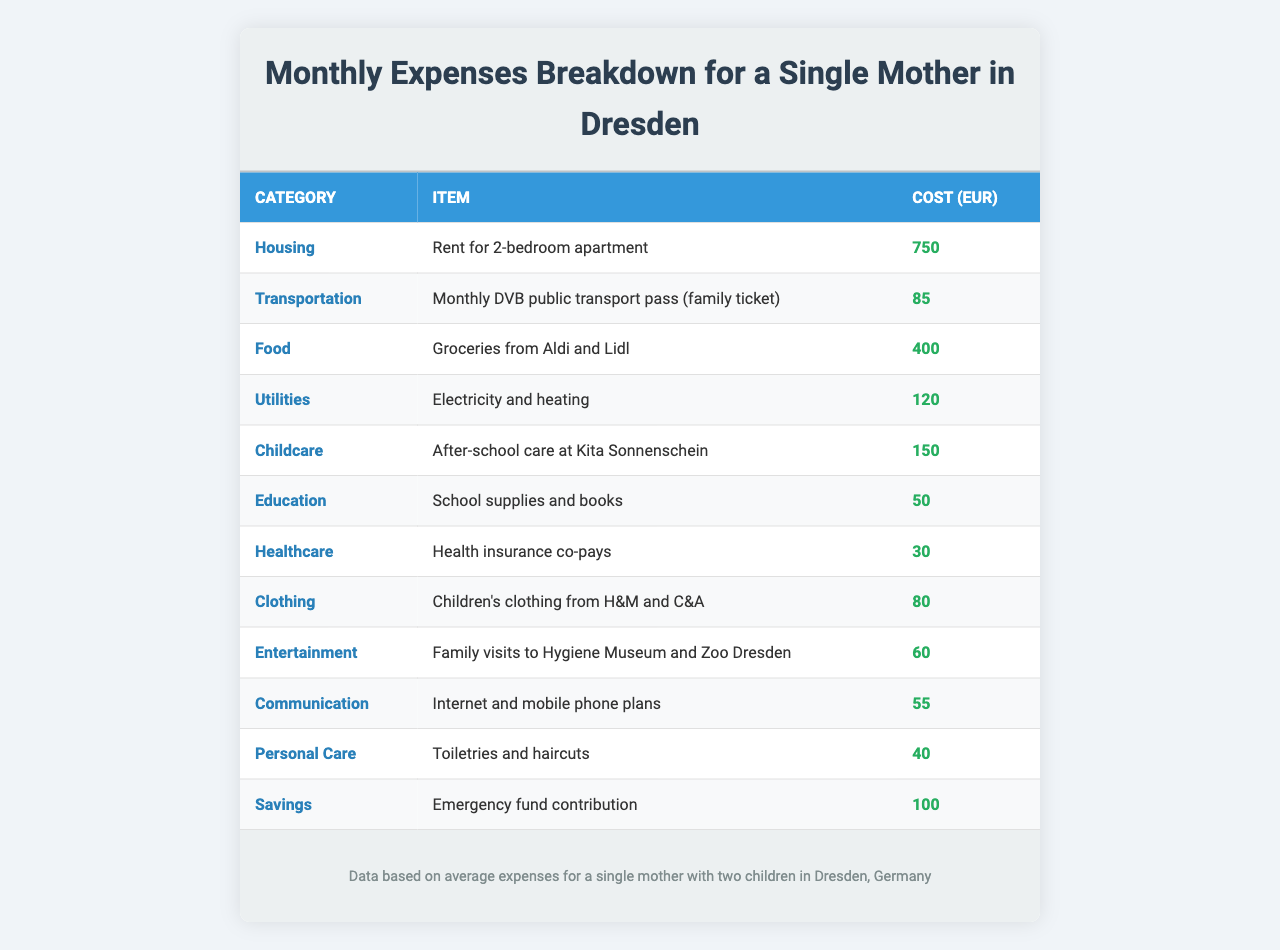What is the total cost for Housing? The table shows that the only item under the Housing category is "Rent for 2-bedroom apartment," which costs 750 EUR.
Answer: 750 EUR What is the cost of the monthly transportation pass? The table lists "Monthly DVB public transport pass (family ticket)" under Transportation with a cost of 85 EUR.
Answer: 85 EUR What is the total amount spent on Food and Childcare? Add the cost for groceries (400 EUR) and after-school care (150 EUR): 400 + 150 = 550 EUR.
Answer: 550 EUR How much does a single mother spend on utilities? The table indicates that "Electricity and heating" costs 120 EUR under the Utilities category.
Answer: 120 EUR Is the expense for healthcare more or less than 50 EUR? The cost for "Health insurance co-pays" is 30 EUR, which is less than 50 EUR.
Answer: Less What is the average cost of all items listed in the table? There are 12 expense items in total. The total cost is 750 + 85 + 400 + 120 + 150 + 50 + 30 + 80 + 60 + 55 + 40 + 100 = 1875 EUR. The average cost is 1875 / 12 = 156.25 EUR.
Answer: 156.25 EUR If a single mother spends 100 EUR on savings, what is the remaining amount from the total monthly expenses? The total monthly expenses are 1875 EUR, and if 100 EUR is set aside for savings, the remaining amount is 1875 - 100 = 1775 EUR.
Answer: 1775 EUR What is the total amount spent on Entertainment and Personal Care? Add the costs for "Family visits to Hygiene Museum and Zoo Dresden" (60 EUR) and "Toiletries and haircuts" (40 EUR): 60 + 40 = 100 EUR.
Answer: 100 EUR Which category has the highest expense? The highest expense is in the Housing category with the rent for a 2-bedroom apartment costing 750 EUR, which is greater than all other individual items in the table.
Answer: Housing How much does the mother spend on childcare compared to food expenses? The childcare cost is 150 EUR, and the food expense is 400 EUR. 150 EUR is significantly lower than 400 EUR.
Answer: Childcare is lower What is the total cost across all categories? Sum the costs of all items in the table: 750 + 85 + 400 + 120 + 150 + 50 + 30 + 80 + 60 + 55 + 40 + 100 = 1875 EUR.
Answer: 1875 EUR 